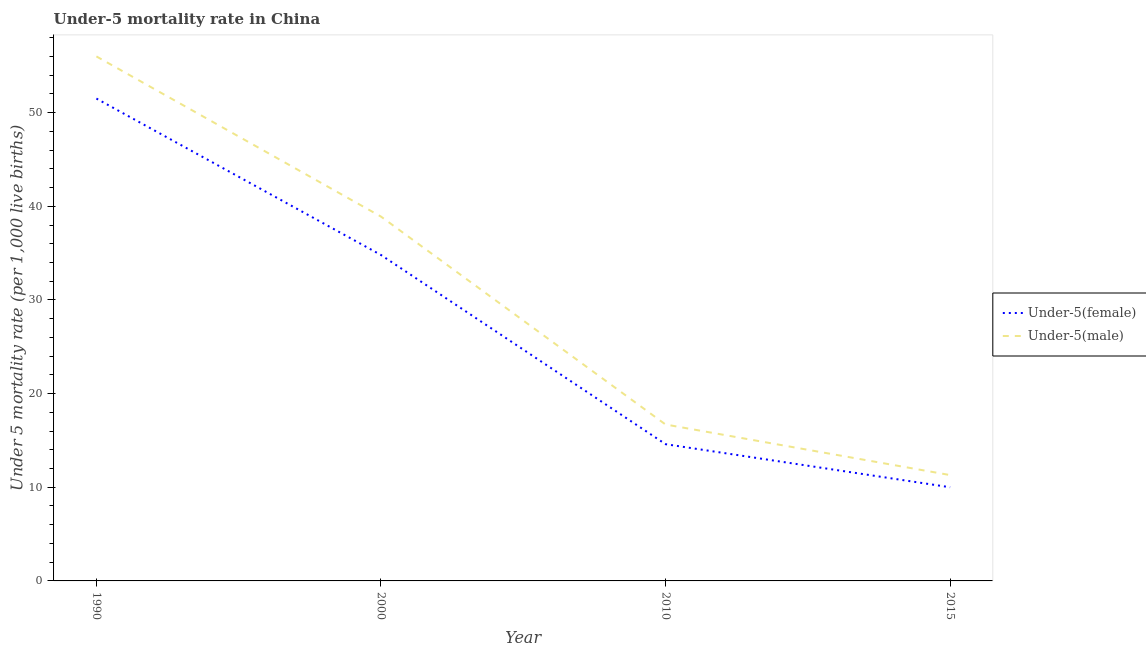How many different coloured lines are there?
Keep it short and to the point. 2. Does the line corresponding to under-5 male mortality rate intersect with the line corresponding to under-5 female mortality rate?
Your answer should be very brief. No. What is the under-5 male mortality rate in 2000?
Provide a short and direct response. 38.9. Across all years, what is the maximum under-5 male mortality rate?
Provide a short and direct response. 56. In which year was the under-5 male mortality rate minimum?
Make the answer very short. 2015. What is the total under-5 female mortality rate in the graph?
Keep it short and to the point. 110.9. What is the difference between the under-5 male mortality rate in 2010 and that in 2015?
Your answer should be very brief. 5.4. What is the difference between the under-5 female mortality rate in 2000 and the under-5 male mortality rate in 1990?
Provide a short and direct response. -21.2. What is the average under-5 female mortality rate per year?
Offer a terse response. 27.72. In the year 2015, what is the difference between the under-5 female mortality rate and under-5 male mortality rate?
Your answer should be very brief. -1.3. What is the ratio of the under-5 male mortality rate in 1990 to that in 2010?
Your answer should be compact. 3.35. Is the under-5 female mortality rate in 2000 less than that in 2010?
Offer a terse response. No. What is the difference between the highest and the second highest under-5 female mortality rate?
Offer a terse response. 16.7. What is the difference between the highest and the lowest under-5 female mortality rate?
Keep it short and to the point. 41.5. In how many years, is the under-5 male mortality rate greater than the average under-5 male mortality rate taken over all years?
Ensure brevity in your answer.  2. Does the under-5 female mortality rate monotonically increase over the years?
Provide a short and direct response. No. Is the under-5 male mortality rate strictly greater than the under-5 female mortality rate over the years?
Your answer should be very brief. Yes. Is the under-5 male mortality rate strictly less than the under-5 female mortality rate over the years?
Keep it short and to the point. No. How many lines are there?
Keep it short and to the point. 2. What is the difference between two consecutive major ticks on the Y-axis?
Your answer should be very brief. 10. Are the values on the major ticks of Y-axis written in scientific E-notation?
Make the answer very short. No. How many legend labels are there?
Keep it short and to the point. 2. What is the title of the graph?
Provide a short and direct response. Under-5 mortality rate in China. Does "Export" appear as one of the legend labels in the graph?
Your response must be concise. No. What is the label or title of the Y-axis?
Provide a short and direct response. Under 5 mortality rate (per 1,0 live births). What is the Under 5 mortality rate (per 1,000 live births) in Under-5(female) in 1990?
Provide a short and direct response. 51.5. What is the Under 5 mortality rate (per 1,000 live births) of Under-5(female) in 2000?
Provide a succinct answer. 34.8. What is the Under 5 mortality rate (per 1,000 live births) in Under-5(male) in 2000?
Provide a short and direct response. 38.9. What is the Under 5 mortality rate (per 1,000 live births) in Under-5(male) in 2010?
Provide a succinct answer. 16.7. What is the Under 5 mortality rate (per 1,000 live births) in Under-5(female) in 2015?
Offer a very short reply. 10. What is the Under 5 mortality rate (per 1,000 live births) in Under-5(male) in 2015?
Give a very brief answer. 11.3. Across all years, what is the maximum Under 5 mortality rate (per 1,000 live births) in Under-5(female)?
Ensure brevity in your answer.  51.5. Across all years, what is the maximum Under 5 mortality rate (per 1,000 live births) in Under-5(male)?
Keep it short and to the point. 56. What is the total Under 5 mortality rate (per 1,000 live births) of Under-5(female) in the graph?
Offer a terse response. 110.9. What is the total Under 5 mortality rate (per 1,000 live births) in Under-5(male) in the graph?
Ensure brevity in your answer.  122.9. What is the difference between the Under 5 mortality rate (per 1,000 live births) in Under-5(female) in 1990 and that in 2000?
Make the answer very short. 16.7. What is the difference between the Under 5 mortality rate (per 1,000 live births) of Under-5(female) in 1990 and that in 2010?
Ensure brevity in your answer.  36.9. What is the difference between the Under 5 mortality rate (per 1,000 live births) of Under-5(male) in 1990 and that in 2010?
Give a very brief answer. 39.3. What is the difference between the Under 5 mortality rate (per 1,000 live births) in Under-5(female) in 1990 and that in 2015?
Provide a succinct answer. 41.5. What is the difference between the Under 5 mortality rate (per 1,000 live births) of Under-5(male) in 1990 and that in 2015?
Your answer should be very brief. 44.7. What is the difference between the Under 5 mortality rate (per 1,000 live births) in Under-5(female) in 2000 and that in 2010?
Provide a short and direct response. 20.2. What is the difference between the Under 5 mortality rate (per 1,000 live births) of Under-5(male) in 2000 and that in 2010?
Your answer should be very brief. 22.2. What is the difference between the Under 5 mortality rate (per 1,000 live births) in Under-5(female) in 2000 and that in 2015?
Offer a very short reply. 24.8. What is the difference between the Under 5 mortality rate (per 1,000 live births) of Under-5(male) in 2000 and that in 2015?
Provide a short and direct response. 27.6. What is the difference between the Under 5 mortality rate (per 1,000 live births) of Under-5(male) in 2010 and that in 2015?
Your answer should be compact. 5.4. What is the difference between the Under 5 mortality rate (per 1,000 live births) in Under-5(female) in 1990 and the Under 5 mortality rate (per 1,000 live births) in Under-5(male) in 2000?
Your answer should be very brief. 12.6. What is the difference between the Under 5 mortality rate (per 1,000 live births) of Under-5(female) in 1990 and the Under 5 mortality rate (per 1,000 live births) of Under-5(male) in 2010?
Offer a terse response. 34.8. What is the difference between the Under 5 mortality rate (per 1,000 live births) in Under-5(female) in 1990 and the Under 5 mortality rate (per 1,000 live births) in Under-5(male) in 2015?
Your response must be concise. 40.2. What is the difference between the Under 5 mortality rate (per 1,000 live births) of Under-5(female) in 2000 and the Under 5 mortality rate (per 1,000 live births) of Under-5(male) in 2010?
Your response must be concise. 18.1. What is the difference between the Under 5 mortality rate (per 1,000 live births) of Under-5(female) in 2010 and the Under 5 mortality rate (per 1,000 live births) of Under-5(male) in 2015?
Provide a succinct answer. 3.3. What is the average Under 5 mortality rate (per 1,000 live births) in Under-5(female) per year?
Ensure brevity in your answer.  27.73. What is the average Under 5 mortality rate (per 1,000 live births) of Under-5(male) per year?
Offer a very short reply. 30.73. In the year 1990, what is the difference between the Under 5 mortality rate (per 1,000 live births) in Under-5(female) and Under 5 mortality rate (per 1,000 live births) in Under-5(male)?
Ensure brevity in your answer.  -4.5. In the year 2010, what is the difference between the Under 5 mortality rate (per 1,000 live births) of Under-5(female) and Under 5 mortality rate (per 1,000 live births) of Under-5(male)?
Ensure brevity in your answer.  -2.1. In the year 2015, what is the difference between the Under 5 mortality rate (per 1,000 live births) of Under-5(female) and Under 5 mortality rate (per 1,000 live births) of Under-5(male)?
Ensure brevity in your answer.  -1.3. What is the ratio of the Under 5 mortality rate (per 1,000 live births) in Under-5(female) in 1990 to that in 2000?
Offer a terse response. 1.48. What is the ratio of the Under 5 mortality rate (per 1,000 live births) of Under-5(male) in 1990 to that in 2000?
Offer a very short reply. 1.44. What is the ratio of the Under 5 mortality rate (per 1,000 live births) of Under-5(female) in 1990 to that in 2010?
Make the answer very short. 3.53. What is the ratio of the Under 5 mortality rate (per 1,000 live births) in Under-5(male) in 1990 to that in 2010?
Offer a terse response. 3.35. What is the ratio of the Under 5 mortality rate (per 1,000 live births) in Under-5(female) in 1990 to that in 2015?
Your response must be concise. 5.15. What is the ratio of the Under 5 mortality rate (per 1,000 live births) of Under-5(male) in 1990 to that in 2015?
Offer a terse response. 4.96. What is the ratio of the Under 5 mortality rate (per 1,000 live births) of Under-5(female) in 2000 to that in 2010?
Make the answer very short. 2.38. What is the ratio of the Under 5 mortality rate (per 1,000 live births) in Under-5(male) in 2000 to that in 2010?
Give a very brief answer. 2.33. What is the ratio of the Under 5 mortality rate (per 1,000 live births) of Under-5(female) in 2000 to that in 2015?
Offer a terse response. 3.48. What is the ratio of the Under 5 mortality rate (per 1,000 live births) of Under-5(male) in 2000 to that in 2015?
Your answer should be very brief. 3.44. What is the ratio of the Under 5 mortality rate (per 1,000 live births) in Under-5(female) in 2010 to that in 2015?
Keep it short and to the point. 1.46. What is the ratio of the Under 5 mortality rate (per 1,000 live births) in Under-5(male) in 2010 to that in 2015?
Offer a terse response. 1.48. What is the difference between the highest and the lowest Under 5 mortality rate (per 1,000 live births) in Under-5(female)?
Ensure brevity in your answer.  41.5. What is the difference between the highest and the lowest Under 5 mortality rate (per 1,000 live births) of Under-5(male)?
Ensure brevity in your answer.  44.7. 